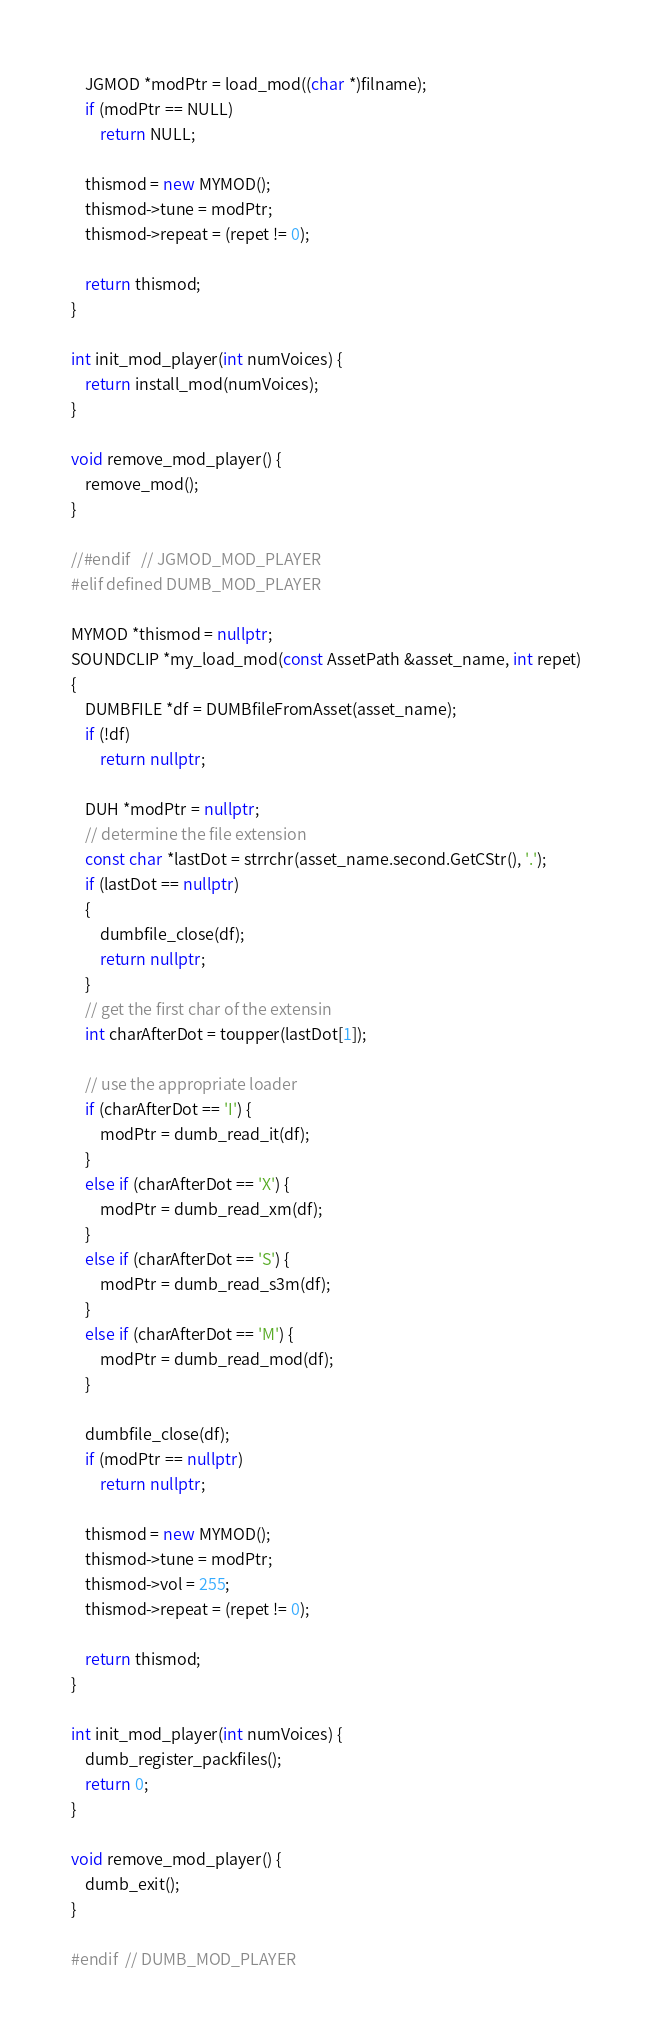Convert code to text. <code><loc_0><loc_0><loc_500><loc_500><_C++_>    JGMOD *modPtr = load_mod((char *)filname);
    if (modPtr == NULL)
        return NULL;

    thismod = new MYMOD();
    thismod->tune = modPtr;
    thismod->repeat = (repet != 0);

    return thismod;
}

int init_mod_player(int numVoices) {
    return install_mod(numVoices);
}

void remove_mod_player() {
    remove_mod();
}

//#endif   // JGMOD_MOD_PLAYER
#elif defined DUMB_MOD_PLAYER

MYMOD *thismod = nullptr;
SOUNDCLIP *my_load_mod(const AssetPath &asset_name, int repet)
{
    DUMBFILE *df = DUMBfileFromAsset(asset_name);
    if (!df)
        return nullptr;

    DUH *modPtr = nullptr;
    // determine the file extension
    const char *lastDot = strrchr(asset_name.second.GetCStr(), '.');
    if (lastDot == nullptr)
    {
        dumbfile_close(df);
        return nullptr;
    }
    // get the first char of the extensin
    int charAfterDot = toupper(lastDot[1]);

    // use the appropriate loader
    if (charAfterDot == 'I') {
        modPtr = dumb_read_it(df);
    }
    else if (charAfterDot == 'X') {
        modPtr = dumb_read_xm(df);
    }
    else if (charAfterDot == 'S') {
        modPtr = dumb_read_s3m(df);
    }
    else if (charAfterDot == 'M') {
        modPtr = dumb_read_mod(df);
    }

    dumbfile_close(df);
    if (modPtr == nullptr)
        return nullptr;

    thismod = new MYMOD();
    thismod->tune = modPtr;
    thismod->vol = 255;
    thismod->repeat = (repet != 0);

    return thismod;
}

int init_mod_player(int numVoices) {
    dumb_register_packfiles();
    return 0;
}

void remove_mod_player() {
    dumb_exit();
}

#endif  // DUMB_MOD_PLAYER
</code> 